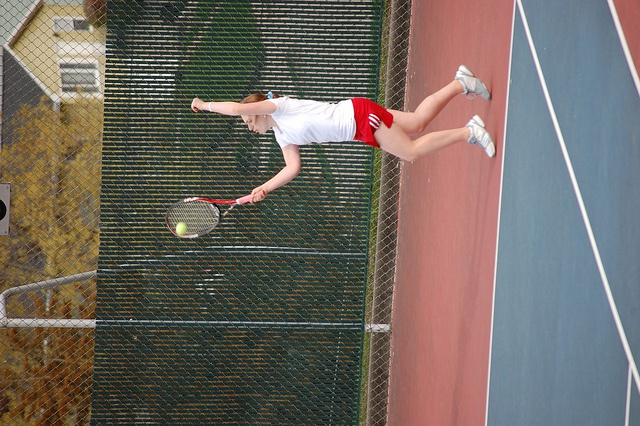Describe the objects in this image and their specific colors. I can see people in darkgray, white, lightpink, salmon, and brown tones, tennis racket in darkgray, gray, tan, and black tones, and sports ball in darkgray, khaki, olive, and lightyellow tones in this image. 